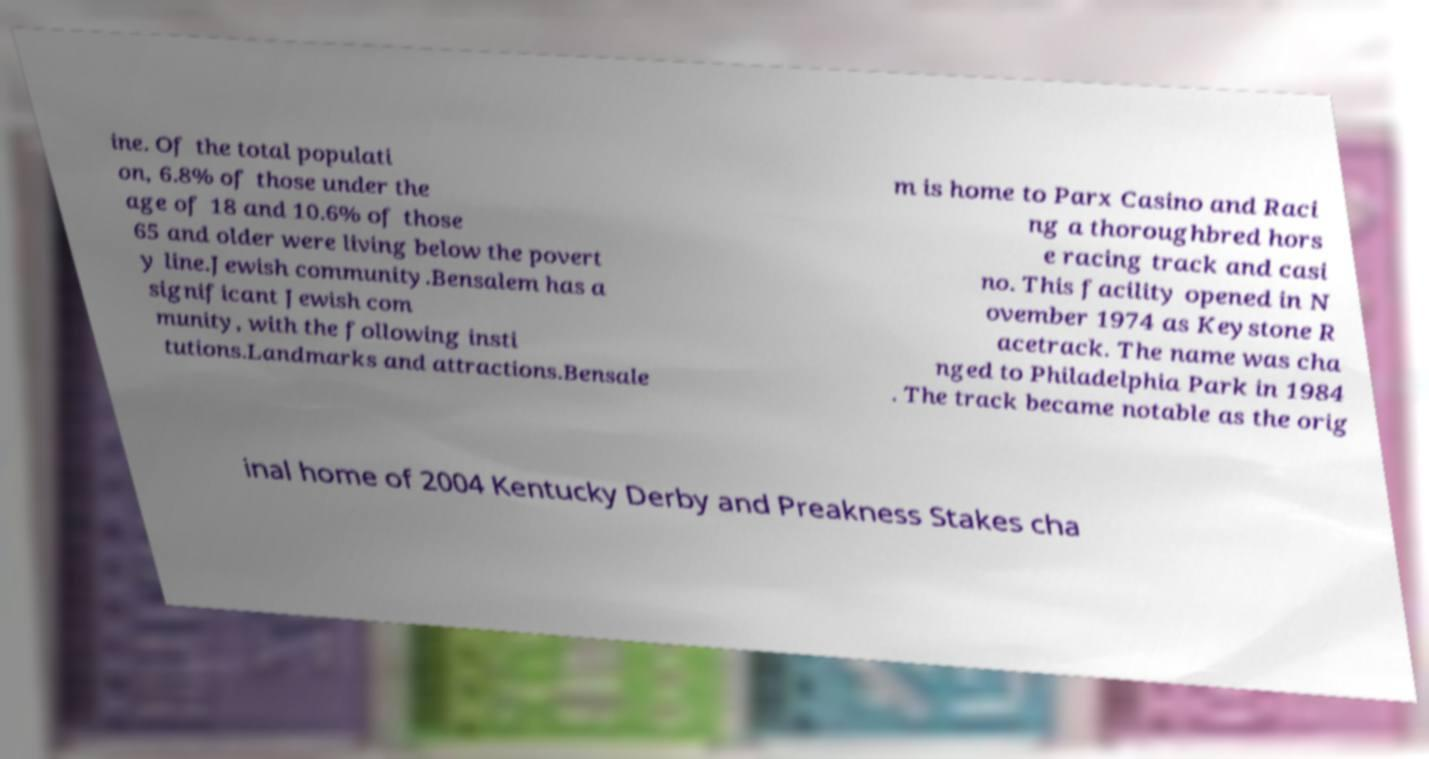Please read and relay the text visible in this image. What does it say? ine. Of the total populati on, 6.8% of those under the age of 18 and 10.6% of those 65 and older were living below the povert y line.Jewish community.Bensalem has a significant Jewish com munity, with the following insti tutions.Landmarks and attractions.Bensale m is home to Parx Casino and Raci ng a thoroughbred hors e racing track and casi no. This facility opened in N ovember 1974 as Keystone R acetrack. The name was cha nged to Philadelphia Park in 1984 . The track became notable as the orig inal home of 2004 Kentucky Derby and Preakness Stakes cha 